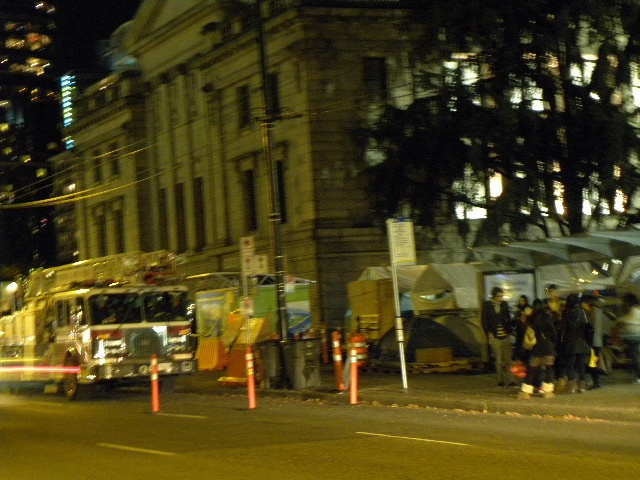Describe the objects in this image and their specific colors. I can see truck in black and olive tones, people in black, olive, and khaki tones, people in black and olive tones, people in black, darkgreen, and olive tones, and people in black and olive tones in this image. 